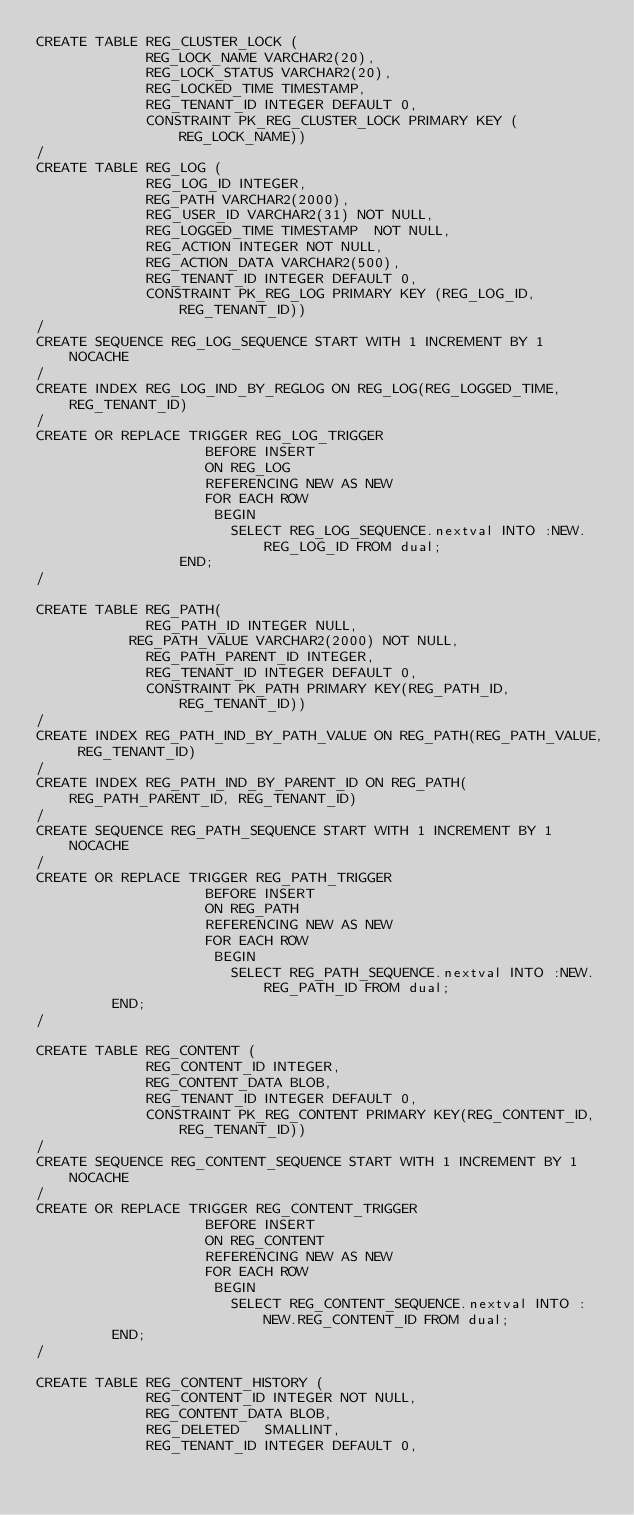<code> <loc_0><loc_0><loc_500><loc_500><_SQL_>CREATE TABLE REG_CLUSTER_LOCK (
             REG_LOCK_NAME VARCHAR2(20),
             REG_LOCK_STATUS VARCHAR2(20),
             REG_LOCKED_TIME TIMESTAMP,
             REG_TENANT_ID INTEGER DEFAULT 0,
             CONSTRAINT PK_REG_CLUSTER_LOCK PRIMARY KEY (REG_LOCK_NAME))
/
CREATE TABLE REG_LOG (
             REG_LOG_ID INTEGER,
             REG_PATH VARCHAR2(2000),
             REG_USER_ID VARCHAR2(31) NOT NULL,
             REG_LOGGED_TIME TIMESTAMP  NOT NULL,
             REG_ACTION INTEGER NOT NULL,
             REG_ACTION_DATA VARCHAR2(500),
             REG_TENANT_ID INTEGER DEFAULT 0,
             CONSTRAINT PK_REG_LOG PRIMARY KEY (REG_LOG_ID, REG_TENANT_ID))
/
CREATE SEQUENCE REG_LOG_SEQUENCE START WITH 1 INCREMENT BY 1 NOCACHE
/
CREATE INDEX REG_LOG_IND_BY_REGLOG ON REG_LOG(REG_LOGGED_TIME, REG_TENANT_ID)
/
CREATE OR REPLACE TRIGGER REG_LOG_TRIGGER
                    BEFORE INSERT
                    ON REG_LOG
                    REFERENCING NEW AS NEW
                    FOR EACH ROW
                     BEGIN
                       SELECT REG_LOG_SEQUENCE.nextval INTO :NEW.REG_LOG_ID FROM dual;
           		   END;
/

CREATE TABLE REG_PATH(
             REG_PATH_ID INTEGER NULL,
	         REG_PATH_VALUE VARCHAR2(2000) NOT NULL,
             REG_PATH_PARENT_ID INTEGER,
             REG_TENANT_ID INTEGER DEFAULT 0,
             CONSTRAINT PK_PATH PRIMARY KEY(REG_PATH_ID, REG_TENANT_ID))
/
CREATE INDEX REG_PATH_IND_BY_PATH_VALUE ON REG_PATH(REG_PATH_VALUE, REG_TENANT_ID)
/
CREATE INDEX REG_PATH_IND_BY_PARENT_ID ON REG_PATH(REG_PATH_PARENT_ID, REG_TENANT_ID)
/
CREATE SEQUENCE REG_PATH_SEQUENCE START WITH 1 INCREMENT BY 1 NOCACHE
/
CREATE OR REPLACE TRIGGER REG_PATH_TRIGGER
                    BEFORE INSERT
                    ON REG_PATH
                    REFERENCING NEW AS NEW
                    FOR EACH ROW
                     BEGIN
                       SELECT REG_PATH_SEQUENCE.nextval INTO :NEW.REG_PATH_ID FROM dual;
 			   END;
/

CREATE TABLE REG_CONTENT (
             REG_CONTENT_ID INTEGER,
             REG_CONTENT_DATA BLOB,
             REG_TENANT_ID INTEGER DEFAULT 0,
             CONSTRAINT PK_REG_CONTENT PRIMARY KEY(REG_CONTENT_ID, REG_TENANT_ID))
/
CREATE SEQUENCE REG_CONTENT_SEQUENCE START WITH 1 INCREMENT BY 1 NOCACHE
/
CREATE OR REPLACE TRIGGER REG_CONTENT_TRIGGER
                    BEFORE INSERT
                    ON REG_CONTENT
                    REFERENCING NEW AS NEW
                    FOR EACH ROW
                     BEGIN
                       SELECT REG_CONTENT_SEQUENCE.nextval INTO :NEW.REG_CONTENT_ID FROM dual;
 			   END;
/

CREATE TABLE REG_CONTENT_HISTORY (
             REG_CONTENT_ID INTEGER NOT NULL,
             REG_CONTENT_DATA BLOB,
             REG_DELETED   SMALLINT,
             REG_TENANT_ID INTEGER DEFAULT 0,</code> 